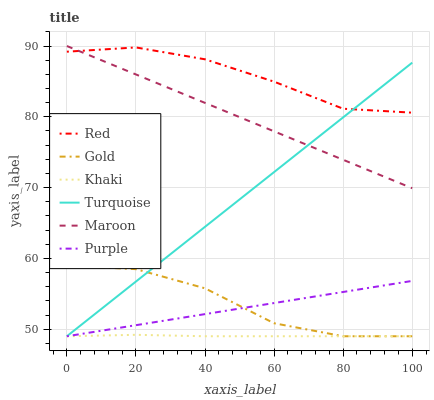Does Khaki have the minimum area under the curve?
Answer yes or no. Yes. Does Red have the maximum area under the curve?
Answer yes or no. Yes. Does Gold have the minimum area under the curve?
Answer yes or no. No. Does Gold have the maximum area under the curve?
Answer yes or no. No. Is Purple the smoothest?
Answer yes or no. Yes. Is Gold the roughest?
Answer yes or no. Yes. Is Khaki the smoothest?
Answer yes or no. No. Is Khaki the roughest?
Answer yes or no. No. Does Turquoise have the lowest value?
Answer yes or no. Yes. Does Maroon have the lowest value?
Answer yes or no. No. Does Maroon have the highest value?
Answer yes or no. Yes. Does Gold have the highest value?
Answer yes or no. No. Is Gold less than Red?
Answer yes or no. Yes. Is Maroon greater than Gold?
Answer yes or no. Yes. Does Gold intersect Turquoise?
Answer yes or no. Yes. Is Gold less than Turquoise?
Answer yes or no. No. Is Gold greater than Turquoise?
Answer yes or no. No. Does Gold intersect Red?
Answer yes or no. No. 